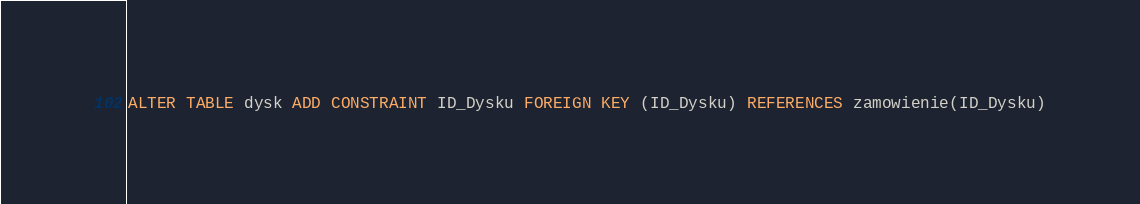Convert code to text. <code><loc_0><loc_0><loc_500><loc_500><_SQL_>ALTER TABLE dysk ADD CONSTRAINT ID_Dysku FOREIGN KEY (ID_Dysku) REFERENCES zamowienie(ID_Dysku)</code> 